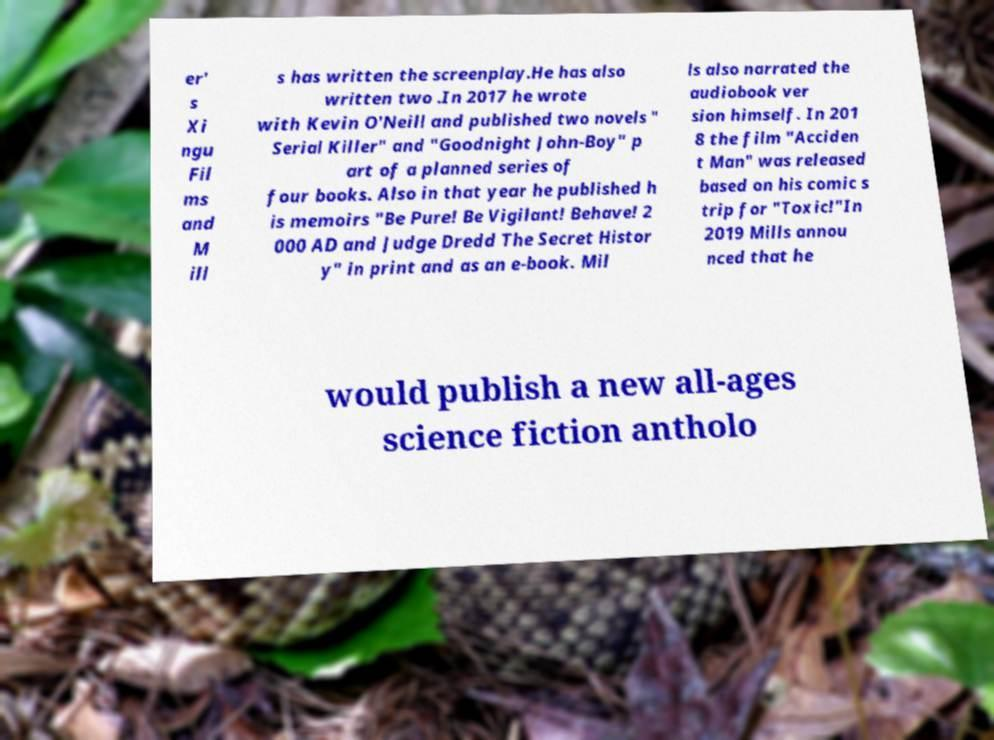Can you read and provide the text displayed in the image?This photo seems to have some interesting text. Can you extract and type it out for me? er' s Xi ngu Fil ms and M ill s has written the screenplay.He has also written two .In 2017 he wrote with Kevin O'Neill and published two novels " Serial Killer" and "Goodnight John-Boy" p art of a planned series of four books. Also in that year he published h is memoirs "Be Pure! Be Vigilant! Behave! 2 000 AD and Judge Dredd The Secret Histor y" in print and as an e-book. Mil ls also narrated the audiobook ver sion himself. In 201 8 the film "Acciden t Man" was released based on his comic s trip for "Toxic!"In 2019 Mills annou nced that he would publish a new all-ages science fiction antholo 